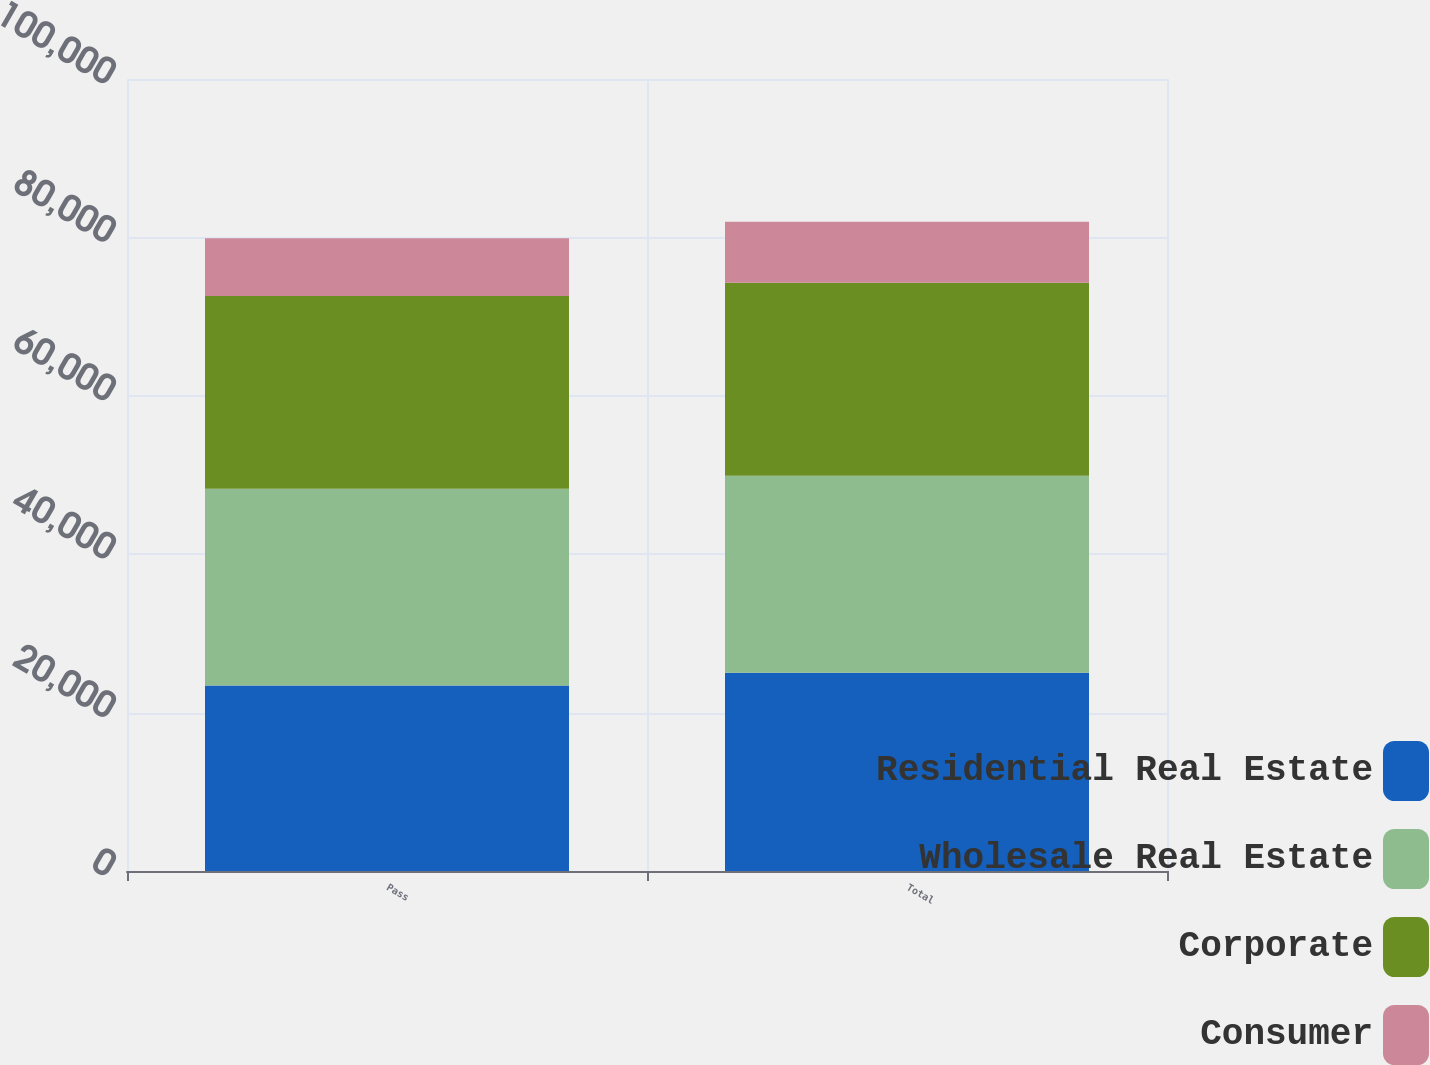Convert chart to OTSL. <chart><loc_0><loc_0><loc_500><loc_500><stacked_bar_chart><ecel><fcel>Pass<fcel>Total<nl><fcel>Residential Real Estate<fcel>23409<fcel>25025<nl><fcel>Wholesale Real Estate<fcel>24853<fcel>24866<nl><fcel>Corporate<fcel>24345<fcel>24385<nl><fcel>Consumer<fcel>7294<fcel>7702<nl></chart> 